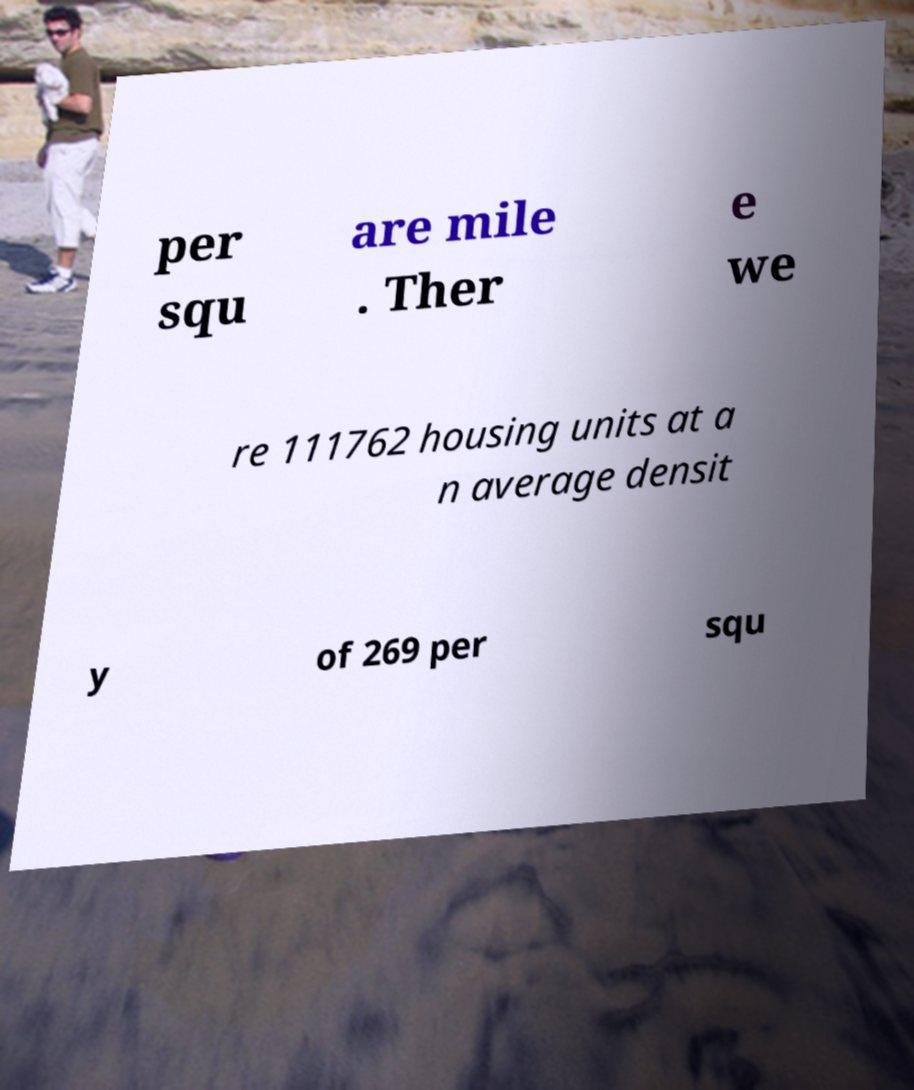Could you assist in decoding the text presented in this image and type it out clearly? per squ are mile . Ther e we re 111762 housing units at a n average densit y of 269 per squ 